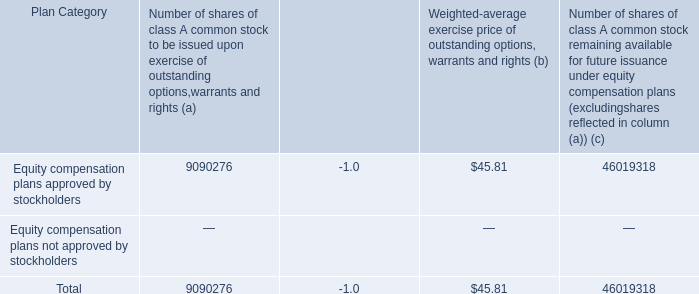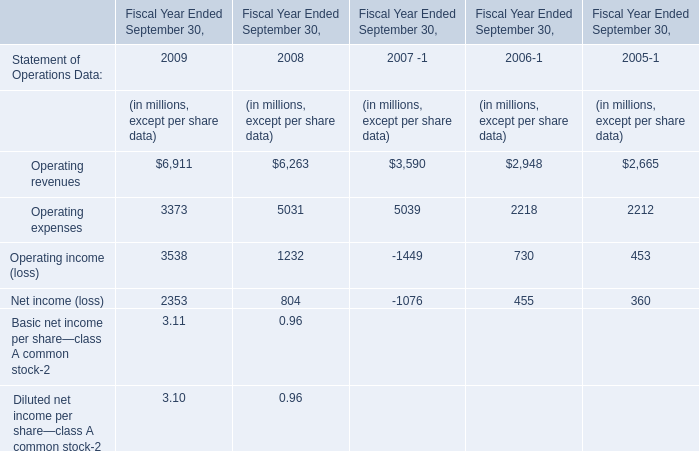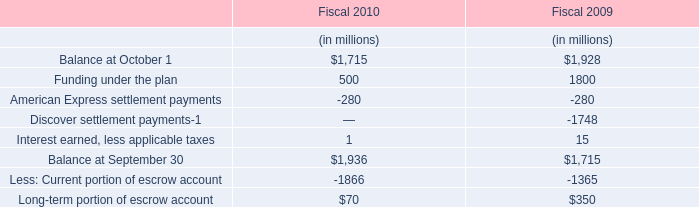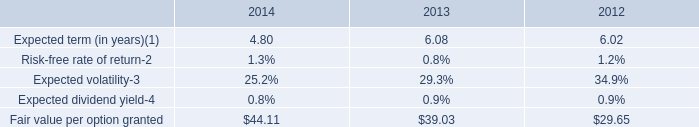what is the total share-based compensation cost in the last three years? 
Computations: ((172 + 179) + 147)
Answer: 498.0. 